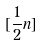Convert formula to latex. <formula><loc_0><loc_0><loc_500><loc_500>[ \frac { 1 } { 2 } n ]</formula> 